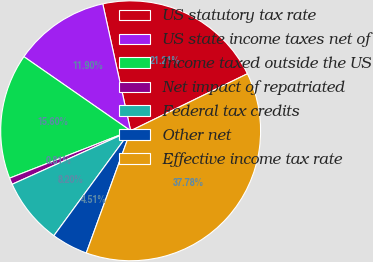Convert chart. <chart><loc_0><loc_0><loc_500><loc_500><pie_chart><fcel>US statutory tax rate<fcel>US state income taxes net of<fcel>Income taxed outside the US<fcel>Net impact of repatriated<fcel>Federal tax credits<fcel>Other net<fcel>Effective income tax rate<nl><fcel>21.21%<fcel>11.9%<fcel>15.6%<fcel>0.81%<fcel>8.2%<fcel>4.51%<fcel>37.78%<nl></chart> 